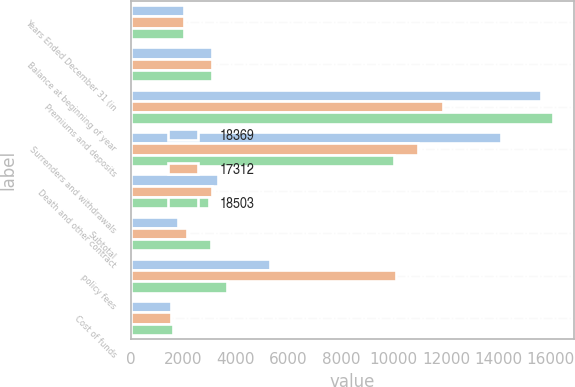Convert chart to OTSL. <chart><loc_0><loc_0><loc_500><loc_500><stacked_bar_chart><ecel><fcel>Years Ended December 31 (in<fcel>Balance at beginning of year<fcel>Premiums and deposits<fcel>Surrenders and withdrawals<fcel>Death and other contract<fcel>Subtotal<fcel>policy fees<fcel>Cost of funds<nl><fcel>18369<fcel>2018<fcel>3089<fcel>15621<fcel>14081<fcel>3316<fcel>1776<fcel>5302<fcel>1540<nl><fcel>17312<fcel>2017<fcel>3089<fcel>11906<fcel>10943<fcel>3089<fcel>2126<fcel>10098<fcel>1528<nl><fcel>18503<fcel>2016<fcel>3089<fcel>16062<fcel>10027<fcel>2991<fcel>3044<fcel>3657<fcel>1614<nl></chart> 